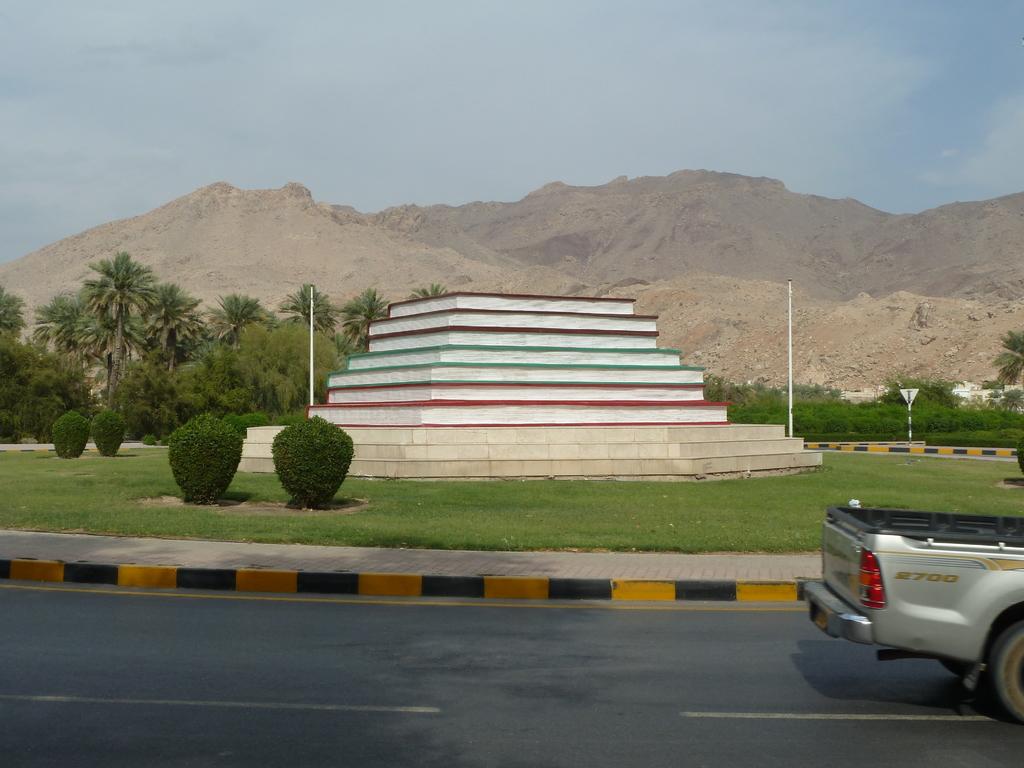What is written on the side of the pickup?
Offer a terse response. 2700. 